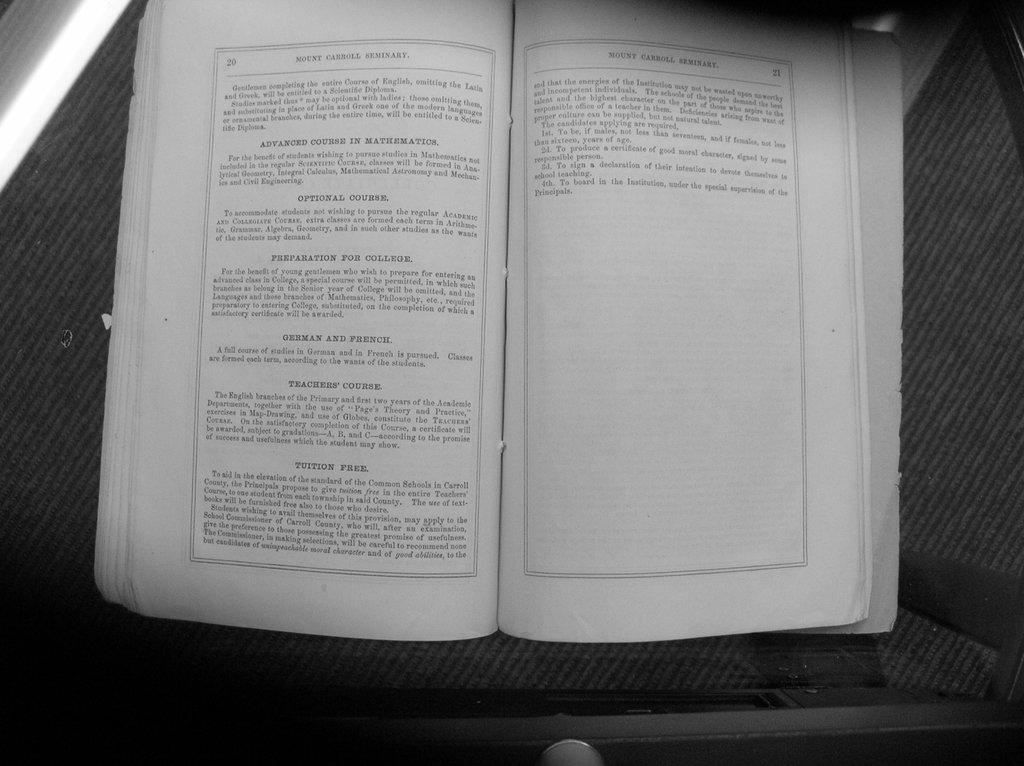<image>
Share a concise interpretation of the image provided. A book is opened to pages 20 and 21. 